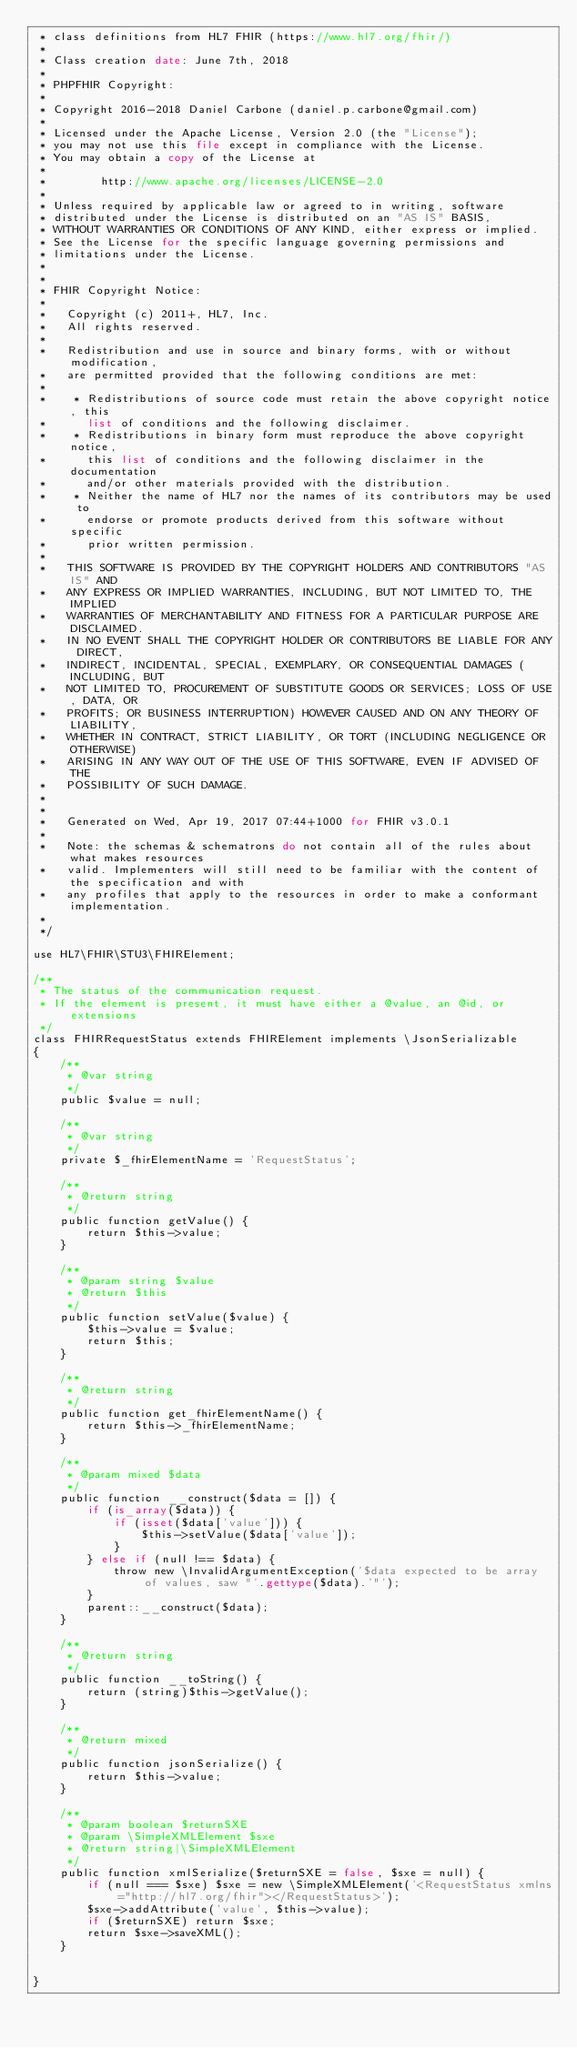<code> <loc_0><loc_0><loc_500><loc_500><_PHP_> * class definitions from HL7 FHIR (https://www.hl7.org/fhir/)
 * 
 * Class creation date: June 7th, 2018
 * 
 * PHPFHIR Copyright:
 * 
 * Copyright 2016-2018 Daniel Carbone (daniel.p.carbone@gmail.com)
 * 
 * Licensed under the Apache License, Version 2.0 (the "License");
 * you may not use this file except in compliance with the License.
 * You may obtain a copy of the License at
 * 
 *        http://www.apache.org/licenses/LICENSE-2.0
 * 
 * Unless required by applicable law or agreed to in writing, software
 * distributed under the License is distributed on an "AS IS" BASIS,
 * WITHOUT WARRANTIES OR CONDITIONS OF ANY KIND, either express or implied.
 * See the License for the specific language governing permissions and
 * limitations under the License.
 * 
 *
 * FHIR Copyright Notice:
 *
 *   Copyright (c) 2011+, HL7, Inc.
 *   All rights reserved.
 * 
 *   Redistribution and use in source and binary forms, with or without modification,
 *   are permitted provided that the following conditions are met:
 * 
 *    * Redistributions of source code must retain the above copyright notice, this
 *      list of conditions and the following disclaimer.
 *    * Redistributions in binary form must reproduce the above copyright notice,
 *      this list of conditions and the following disclaimer in the documentation
 *      and/or other materials provided with the distribution.
 *    * Neither the name of HL7 nor the names of its contributors may be used to
 *      endorse or promote products derived from this software without specific
 *      prior written permission.
 * 
 *   THIS SOFTWARE IS PROVIDED BY THE COPYRIGHT HOLDERS AND CONTRIBUTORS "AS IS" AND
 *   ANY EXPRESS OR IMPLIED WARRANTIES, INCLUDING, BUT NOT LIMITED TO, THE IMPLIED
 *   WARRANTIES OF MERCHANTABILITY AND FITNESS FOR A PARTICULAR PURPOSE ARE DISCLAIMED.
 *   IN NO EVENT SHALL THE COPYRIGHT HOLDER OR CONTRIBUTORS BE LIABLE FOR ANY DIRECT,
 *   INDIRECT, INCIDENTAL, SPECIAL, EXEMPLARY, OR CONSEQUENTIAL DAMAGES (INCLUDING, BUT
 *   NOT LIMITED TO, PROCUREMENT OF SUBSTITUTE GOODS OR SERVICES; LOSS OF USE, DATA, OR
 *   PROFITS; OR BUSINESS INTERRUPTION) HOWEVER CAUSED AND ON ANY THEORY OF LIABILITY,
 *   WHETHER IN CONTRACT, STRICT LIABILITY, OR TORT (INCLUDING NEGLIGENCE OR OTHERWISE)
 *   ARISING IN ANY WAY OUT OF THE USE OF THIS SOFTWARE, EVEN IF ADVISED OF THE
 *   POSSIBILITY OF SUCH DAMAGE.
 * 
 * 
 *   Generated on Wed, Apr 19, 2017 07:44+1000 for FHIR v3.0.1
 * 
 *   Note: the schemas & schematrons do not contain all of the rules about what makes resources
 *   valid. Implementers will still need to be familiar with the content of the specification and with
 *   any profiles that apply to the resources in order to make a conformant implementation.
 * 
 */

use HL7\FHIR\STU3\FHIRElement;

/**
 * The status of the communication request.
 * If the element is present, it must have either a @value, an @id, or extensions
 */
class FHIRRequestStatus extends FHIRElement implements \JsonSerializable
{
    /**
     * @var string
     */
    public $value = null;

    /**
     * @var string
     */
    private $_fhirElementName = 'RequestStatus';

    /**
     * @return string
     */
    public function getValue() {
        return $this->value;
    }

    /**
     * @param string $value
     * @return $this
     */
    public function setValue($value) {
        $this->value = $value;
        return $this;
    }

    /**
     * @return string
     */
    public function get_fhirElementName() {
        return $this->_fhirElementName;
    }

    /**
     * @param mixed $data
     */
    public function __construct($data = []) {
        if (is_array($data)) {
            if (isset($data['value'])) {
                $this->setValue($data['value']);
            }
        } else if (null !== $data) {
            throw new \InvalidArgumentException('$data expected to be array of values, saw "'.gettype($data).'"');
        }
        parent::__construct($data);
    }

    /**
     * @return string
     */
    public function __toString() {
        return (string)$this->getValue();
    }

    /**
     * @return mixed
     */
    public function jsonSerialize() {
        return $this->value;
    }

    /**
     * @param boolean $returnSXE
     * @param \SimpleXMLElement $sxe
     * @return string|\SimpleXMLElement
     */
    public function xmlSerialize($returnSXE = false, $sxe = null) {
        if (null === $sxe) $sxe = new \SimpleXMLElement('<RequestStatus xmlns="http://hl7.org/fhir"></RequestStatus>');
        $sxe->addAttribute('value', $this->value);
        if ($returnSXE) return $sxe;
        return $sxe->saveXML();
    }


}</code> 